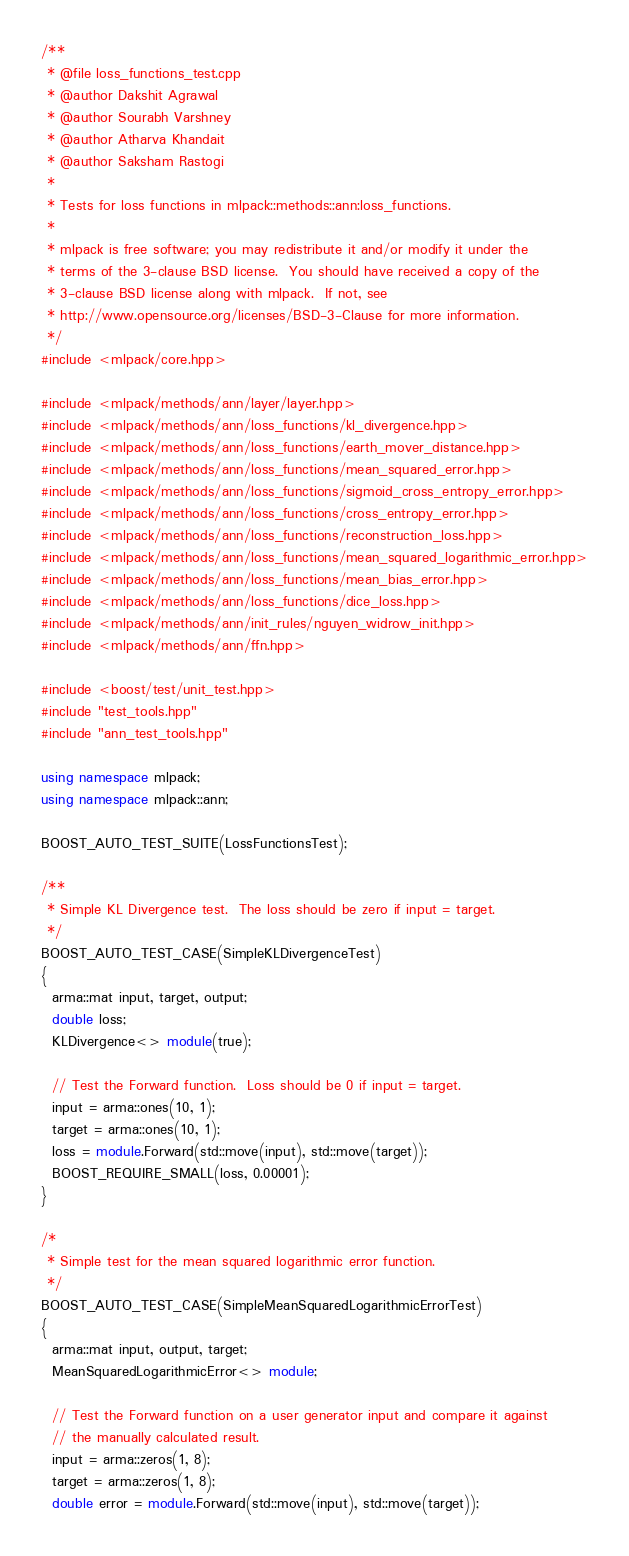Convert code to text. <code><loc_0><loc_0><loc_500><loc_500><_C++_>/**
 * @file loss_functions_test.cpp
 * @author Dakshit Agrawal
 * @author Sourabh Varshney
 * @author Atharva Khandait
 * @author Saksham Rastogi
 *
 * Tests for loss functions in mlpack::methods::ann:loss_functions.
 *
 * mlpack is free software; you may redistribute it and/or modify it under the
 * terms of the 3-clause BSD license.  You should have received a copy of the
 * 3-clause BSD license along with mlpack.  If not, see
 * http://www.opensource.org/licenses/BSD-3-Clause for more information.
 */
#include <mlpack/core.hpp>

#include <mlpack/methods/ann/layer/layer.hpp>
#include <mlpack/methods/ann/loss_functions/kl_divergence.hpp>
#include <mlpack/methods/ann/loss_functions/earth_mover_distance.hpp>
#include <mlpack/methods/ann/loss_functions/mean_squared_error.hpp>
#include <mlpack/methods/ann/loss_functions/sigmoid_cross_entropy_error.hpp>
#include <mlpack/methods/ann/loss_functions/cross_entropy_error.hpp>
#include <mlpack/methods/ann/loss_functions/reconstruction_loss.hpp>
#include <mlpack/methods/ann/loss_functions/mean_squared_logarithmic_error.hpp>
#include <mlpack/methods/ann/loss_functions/mean_bias_error.hpp>
#include <mlpack/methods/ann/loss_functions/dice_loss.hpp>
#include <mlpack/methods/ann/init_rules/nguyen_widrow_init.hpp>
#include <mlpack/methods/ann/ffn.hpp>

#include <boost/test/unit_test.hpp>
#include "test_tools.hpp"
#include "ann_test_tools.hpp"

using namespace mlpack;
using namespace mlpack::ann;

BOOST_AUTO_TEST_SUITE(LossFunctionsTest);

/**
 * Simple KL Divergence test.  The loss should be zero if input = target.
 */
BOOST_AUTO_TEST_CASE(SimpleKLDivergenceTest)
{
  arma::mat input, target, output;
  double loss;
  KLDivergence<> module(true);

  // Test the Forward function.  Loss should be 0 if input = target.
  input = arma::ones(10, 1);
  target = arma::ones(10, 1);
  loss = module.Forward(std::move(input), std::move(target));
  BOOST_REQUIRE_SMALL(loss, 0.00001);
}

/*
 * Simple test for the mean squared logarithmic error function.
 */
BOOST_AUTO_TEST_CASE(SimpleMeanSquaredLogarithmicErrorTest)
{
  arma::mat input, output, target;
  MeanSquaredLogarithmicError<> module;

  // Test the Forward function on a user generator input and compare it against
  // the manually calculated result.
  input = arma::zeros(1, 8);
  target = arma::zeros(1, 8);
  double error = module.Forward(std::move(input), std::move(target));</code> 